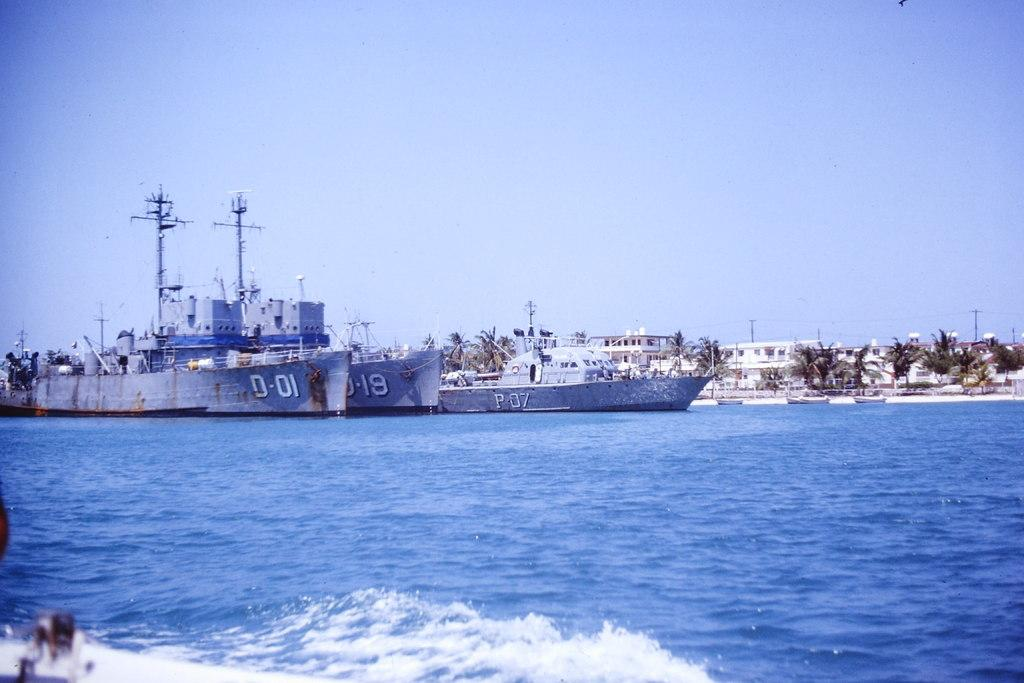What is located at the bottom side of the image? There is water at the bottom side of the image. What can be seen in the center of the image? There are trees in the center of the image. What animals are present in the water? There are birds in the water. What is visible throughout the image? There is water visible in the image. Can you see any fog in the image? There is no mention of fog in the image, so it cannot be determined if it is present or not. What suggestion does the image give about the location? The image does not provide any explicit suggestions about the location, but it does show water, trees, and birds, which could suggest a natural setting. 